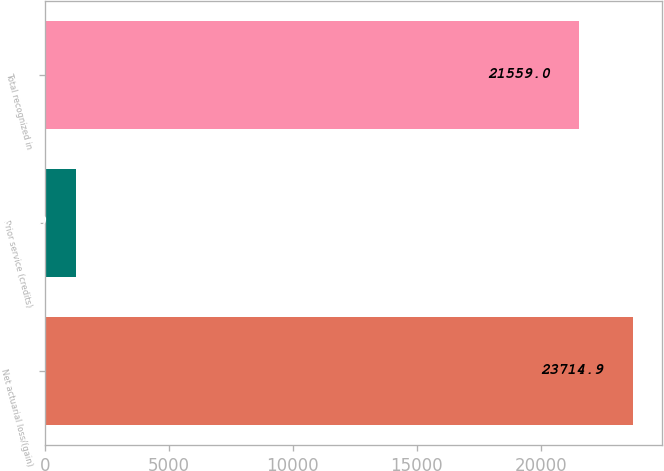<chart> <loc_0><loc_0><loc_500><loc_500><bar_chart><fcel>Net actuarial loss/(gain)<fcel>Prior service (credits)<fcel>Total recognized in<nl><fcel>23714.9<fcel>1243<fcel>21559<nl></chart> 